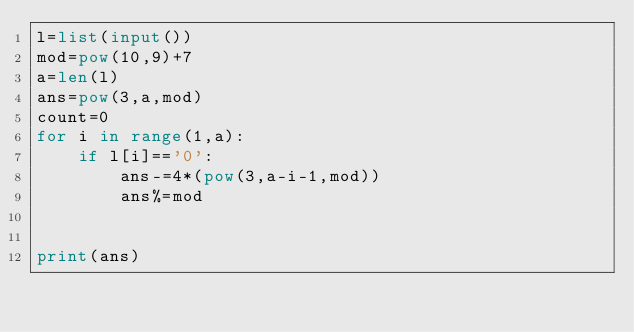<code> <loc_0><loc_0><loc_500><loc_500><_Python_>l=list(input())
mod=pow(10,9)+7
a=len(l)
ans=pow(3,a,mod)
count=0
for i in range(1,a):
    if l[i]=='0':
        ans-=4*(pow(3,a-i-1,mod))
        ans%=mod


print(ans)</code> 